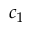<formula> <loc_0><loc_0><loc_500><loc_500>c _ { 1 }</formula> 